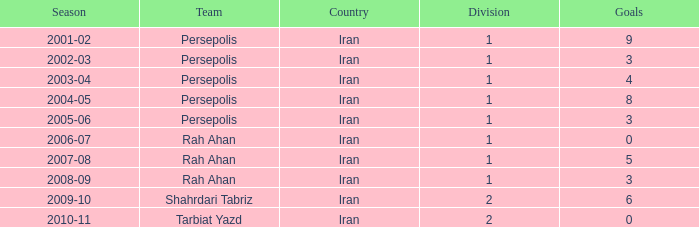What is the total of goals, when season is "2005-06", and when division is below 1? None. 